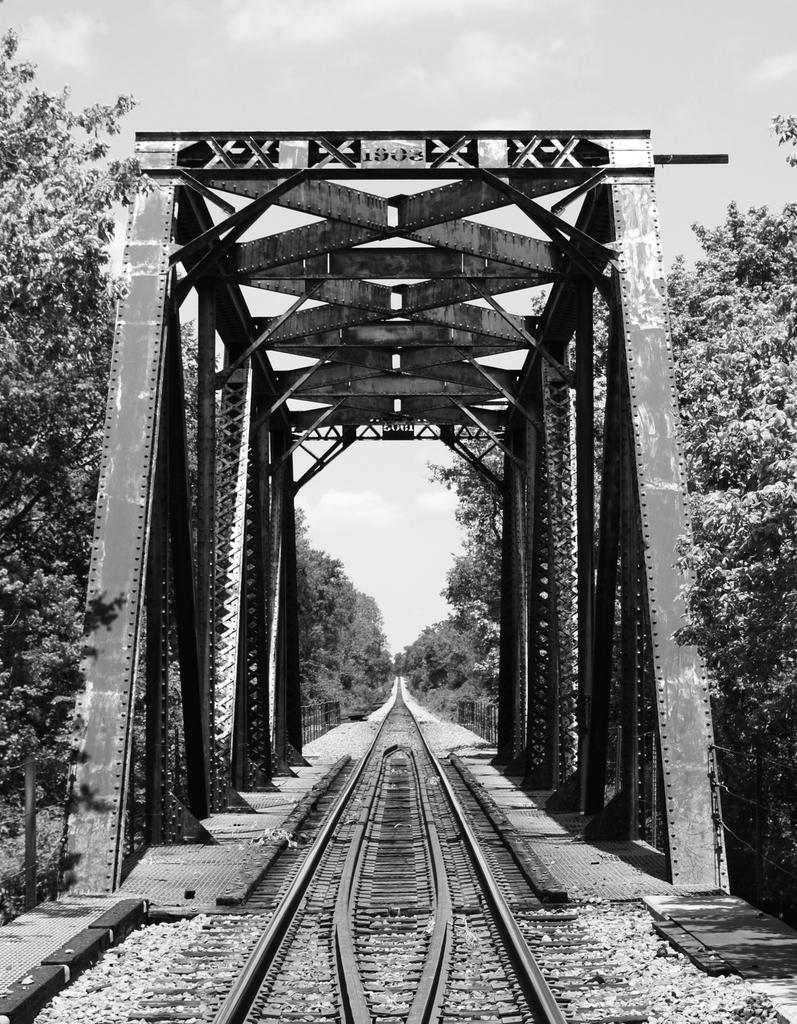What is the color scheme of the image? The image is black and white. What can be seen on the ground in the image? There is a track and stones visible in the image. What type of structure is present in the image? There is a metal bridge in the image. What type of vegetation is present in the image? There are trees in the image. What is visible in the background of the image? The sky is visible in the image. How many oranges are hanging from the trees in the image? There are no oranges present in the image; it features trees without fruit. What unit of measurement is used to determine the length of the metal bridge in the image? There is no information provided about the length of the metal bridge or any unit of measurement used in the image. 